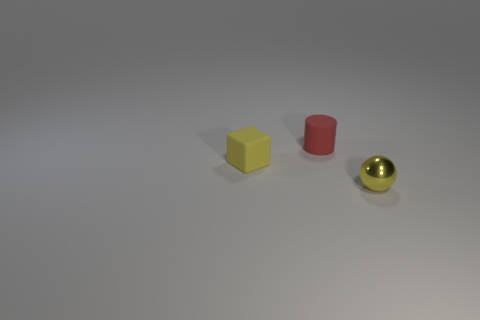Are there any small things made of the same material as the tiny cylinder?
Offer a very short reply. Yes. Does the tiny cylinder have the same material as the tiny block?
Keep it short and to the point. Yes. What number of small red things are in front of the small yellow thing left of the rubber cylinder?
Provide a succinct answer. 0. How many yellow things are either blocks or tiny shiny things?
Provide a short and direct response. 2. What is the shape of the small yellow object that is to the left of the tiny yellow object in front of the yellow object to the left of the red matte thing?
Ensure brevity in your answer.  Cube. There is a cylinder that is the same size as the yellow block; what color is it?
Give a very brief answer. Red. What number of other things have the same shape as the small yellow metallic thing?
Make the answer very short. 0. There is a yellow rubber cube; does it have the same size as the yellow thing on the right side of the matte cylinder?
Your answer should be very brief. Yes. There is a tiny yellow object behind the tiny thing to the right of the cylinder; what is its shape?
Make the answer very short. Cube. Is the number of yellow blocks that are to the right of the red rubber cylinder less than the number of gray rubber balls?
Your answer should be very brief. No. 